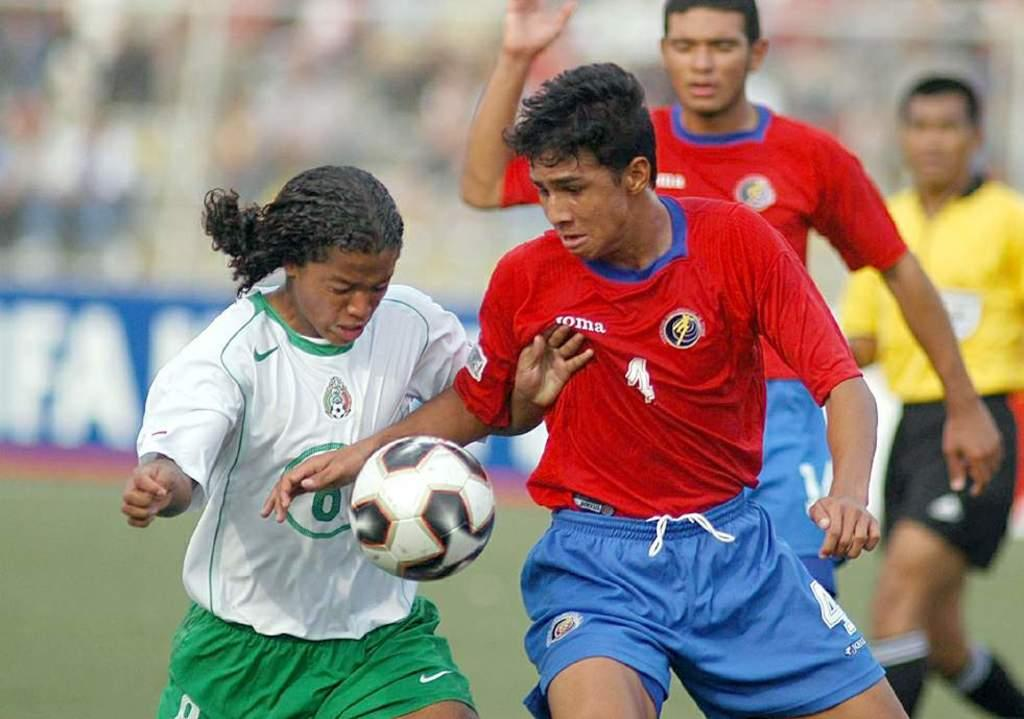<image>
Relay a brief, clear account of the picture shown. 2 soccer players fighting for a ball and one of them has a name on his shirt 